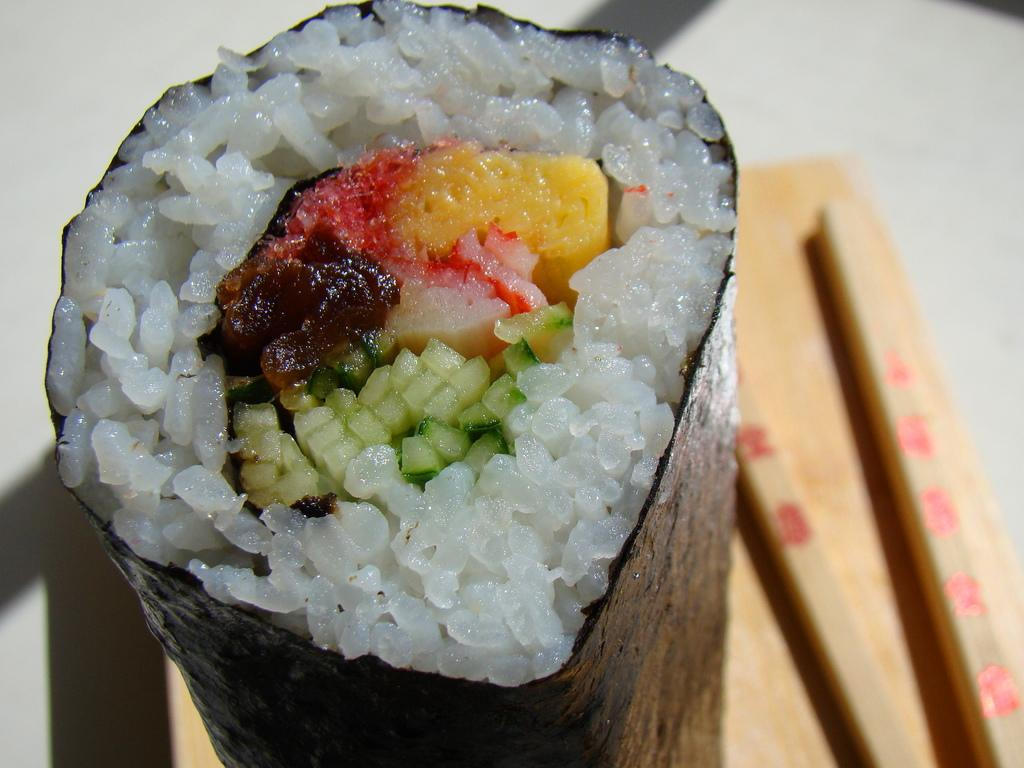What type of food item is wrapped in paper in the image? There is a food item with rice wrapped in a paper in the image. Where is the food item placed? The food item is placed on a table. What utensils are present in the image? There are two sticks present in the image. What type of headwear is the person wearing in the image? There is no person present in the image, so it is not possible to determine what type of headwear they might be wearing. 